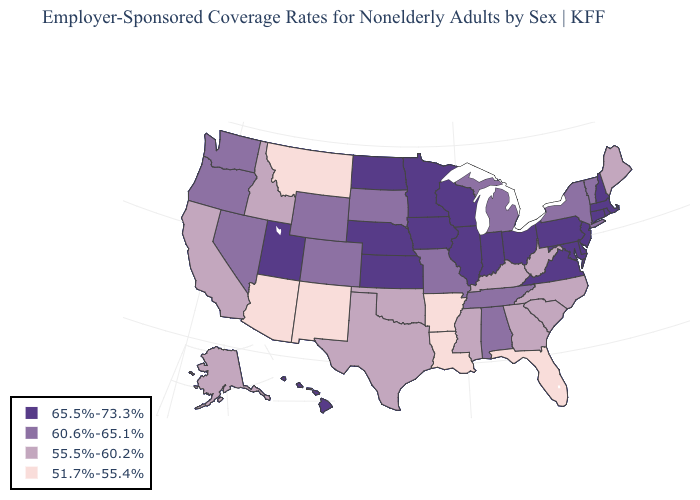Which states have the lowest value in the USA?
Keep it brief. Arizona, Arkansas, Florida, Louisiana, Montana, New Mexico. Among the states that border Connecticut , which have the lowest value?
Quick response, please. New York. Name the states that have a value in the range 60.6%-65.1%?
Short answer required. Alabama, Colorado, Michigan, Missouri, Nevada, New York, Oregon, South Dakota, Tennessee, Vermont, Washington, Wyoming. Name the states that have a value in the range 51.7%-55.4%?
Answer briefly. Arizona, Arkansas, Florida, Louisiana, Montana, New Mexico. What is the lowest value in states that border South Dakota?
Give a very brief answer. 51.7%-55.4%. Name the states that have a value in the range 55.5%-60.2%?
Concise answer only. Alaska, California, Georgia, Idaho, Kentucky, Maine, Mississippi, North Carolina, Oklahoma, South Carolina, Texas, West Virginia. What is the value of Alabama?
Concise answer only. 60.6%-65.1%. Is the legend a continuous bar?
Answer briefly. No. Is the legend a continuous bar?
Short answer required. No. Name the states that have a value in the range 60.6%-65.1%?
Quick response, please. Alabama, Colorado, Michigan, Missouri, Nevada, New York, Oregon, South Dakota, Tennessee, Vermont, Washington, Wyoming. Which states have the lowest value in the MidWest?
Short answer required. Michigan, Missouri, South Dakota. Does the map have missing data?
Be succinct. No. What is the value of Wyoming?
Answer briefly. 60.6%-65.1%. What is the value of Colorado?
Be succinct. 60.6%-65.1%. Which states have the lowest value in the South?
Quick response, please. Arkansas, Florida, Louisiana. 